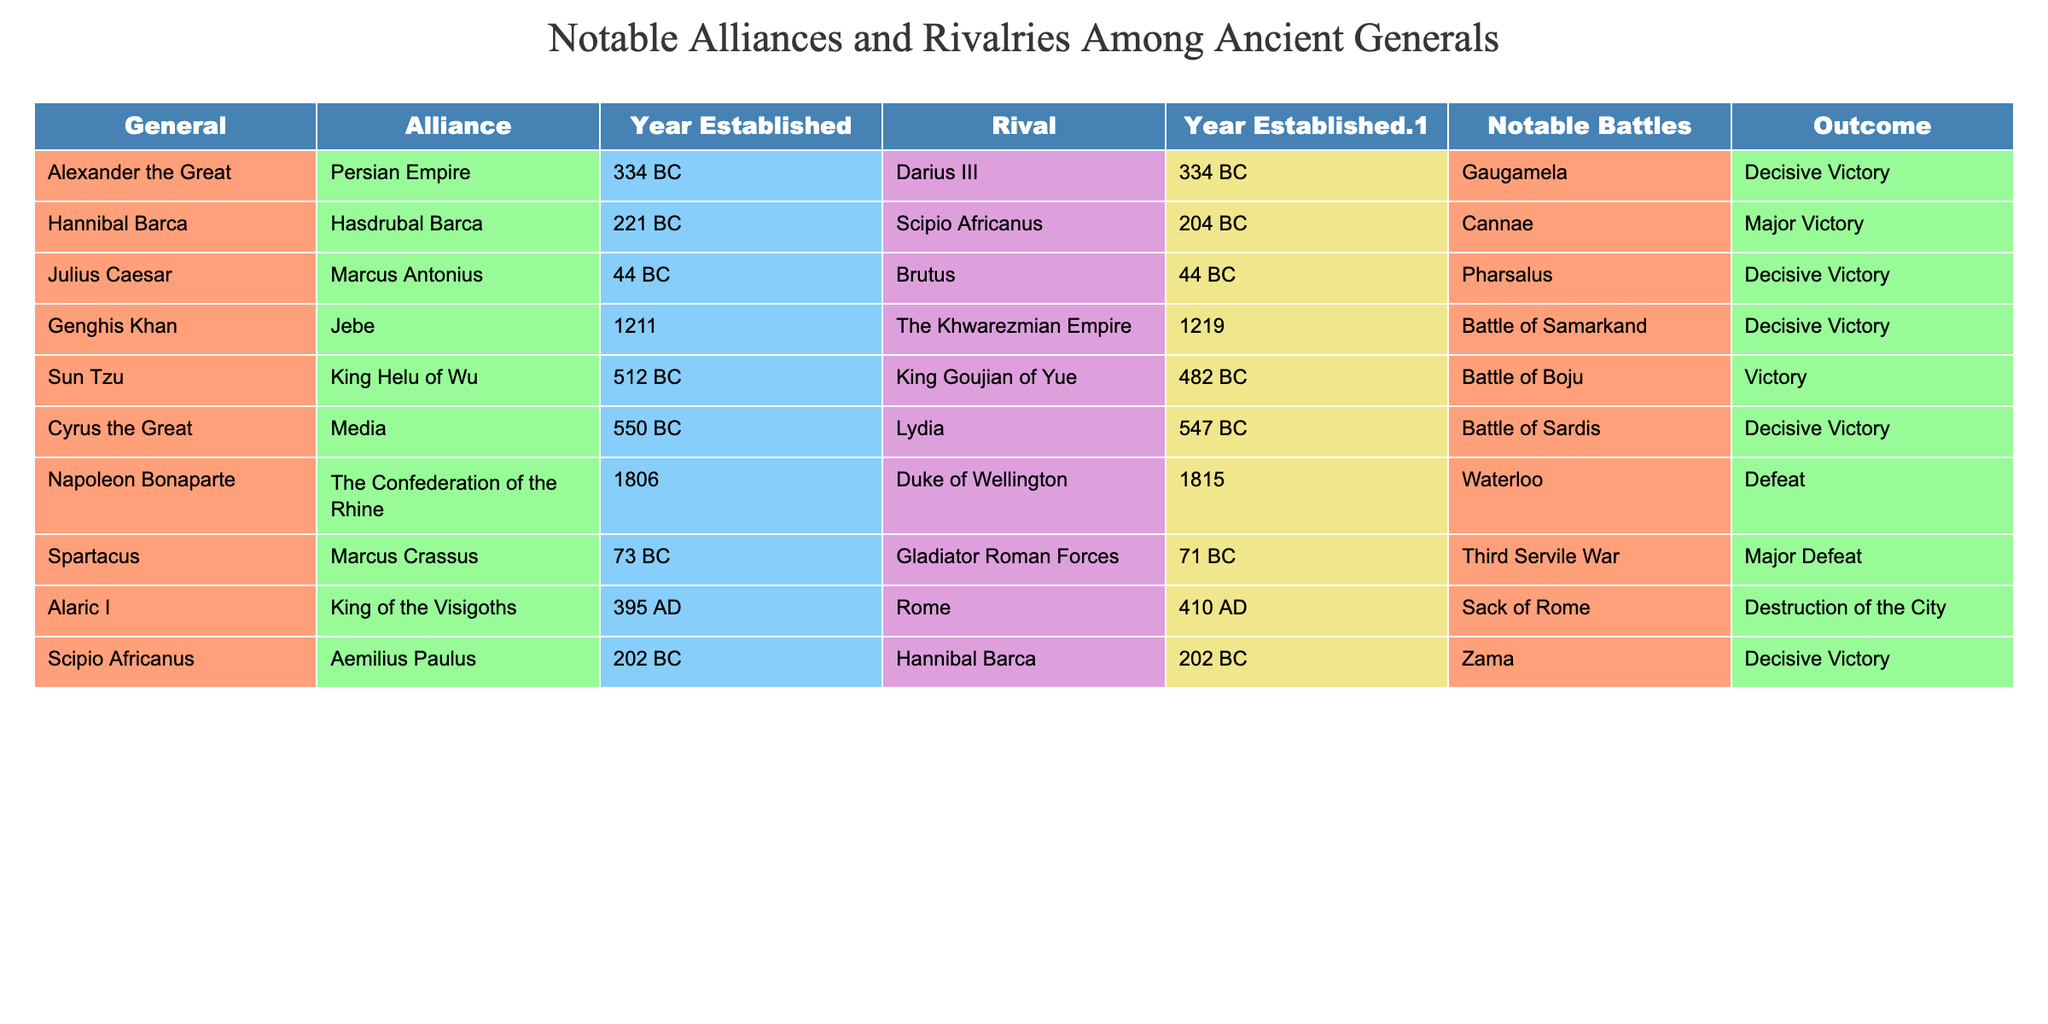What general established an alliance with the Persian Empire? According to the table, Alexander the Great formed an alliance with the Persian Empire in 334 BC.
Answer: Alexander the Great Who was Hannibal Barca’s most notable rival? The table lists Scipio Africanus as Hannibal Barca's most notable rival, established in 204 BC.
Answer: Scipio Africanus In which year did Julius Caesar establish an alliance with Marcus Antonius? The table indicates that Julius Caesar established his alliance with Marcus Antonius in 44 BC.
Answer: 44 BC How many notable battles did Genghis Khan fight against rivals? Genghis Khan is noted to have fought in one significant battle against his rivals, the Battle of Samarkand, as per the table.
Answer: 1 What was the outcome of the Battle of Waterloo involving Napoleon Bonaparte? The table states that the outcome of the Battle of Waterloo was a defeat for Napoleon Bonaparte.
Answer: Defeat What is the year difference between the establishment of the alliance and rivalry for Cyrus the Great? Cyrus the Great established his alliance with Media in 550 BC and his rivalry with Lydia in 547 BC, so the difference is 3 years.
Answer: 3 years Did Alaric I successfully sack Rome? The table shows that Alaric I's action led to the destruction of Rome in 410 AD, indicating a success in sacking the city.
Answer: Yes How many generals are noted for having established alliances in 334 BC? Both Alexander the Great and Darius III established alliances in 334 BC, which makes a total of two generals.
Answer: 2 Which general defeated Hannibal Barca in notable battles? The table identifies Scipio Africanus as the general who defeated Hannibal Barca in the Battle of Zama, both occurring in 202 BC.
Answer: Scipio Africanus If we look at the outcomes of the battles listed, how many resulted in decisive victories? By reviewing the table outcomes, there are five battles that resulted in decisive victories: Gaugamela, Pharsalus, Battle of Samarkand, Battle of Sardis, and Zama.
Answer: 5 